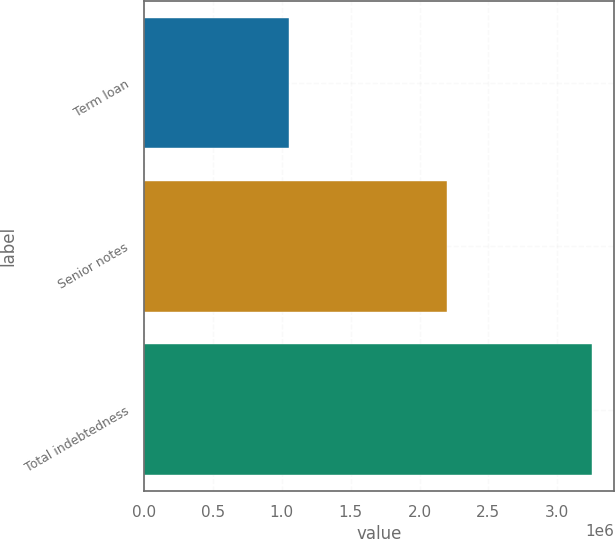Convert chart. <chart><loc_0><loc_0><loc_500><loc_500><bar_chart><fcel>Term loan<fcel>Senior notes<fcel>Total indebtedness<nl><fcel>1.05e+06<fcel>2.2e+06<fcel>3.25e+06<nl></chart> 